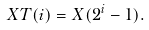Convert formula to latex. <formula><loc_0><loc_0><loc_500><loc_500>X T ( i ) = X ( 2 ^ { i } - 1 ) .</formula> 